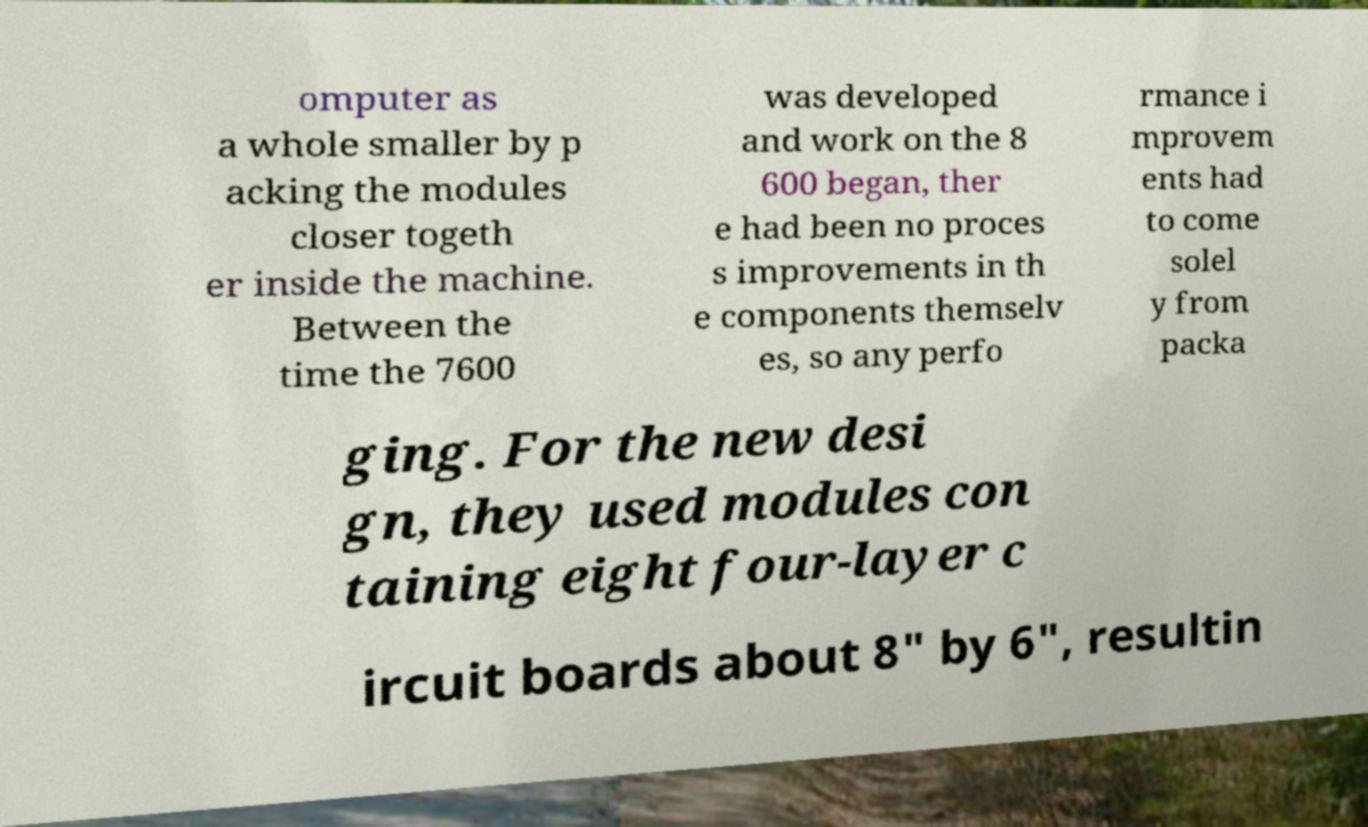Please identify and transcribe the text found in this image. omputer as a whole smaller by p acking the modules closer togeth er inside the machine. Between the time the 7600 was developed and work on the 8 600 began, ther e had been no proces s improvements in th e components themselv es, so any perfo rmance i mprovem ents had to come solel y from packa ging. For the new desi gn, they used modules con taining eight four-layer c ircuit boards about 8" by 6", resultin 